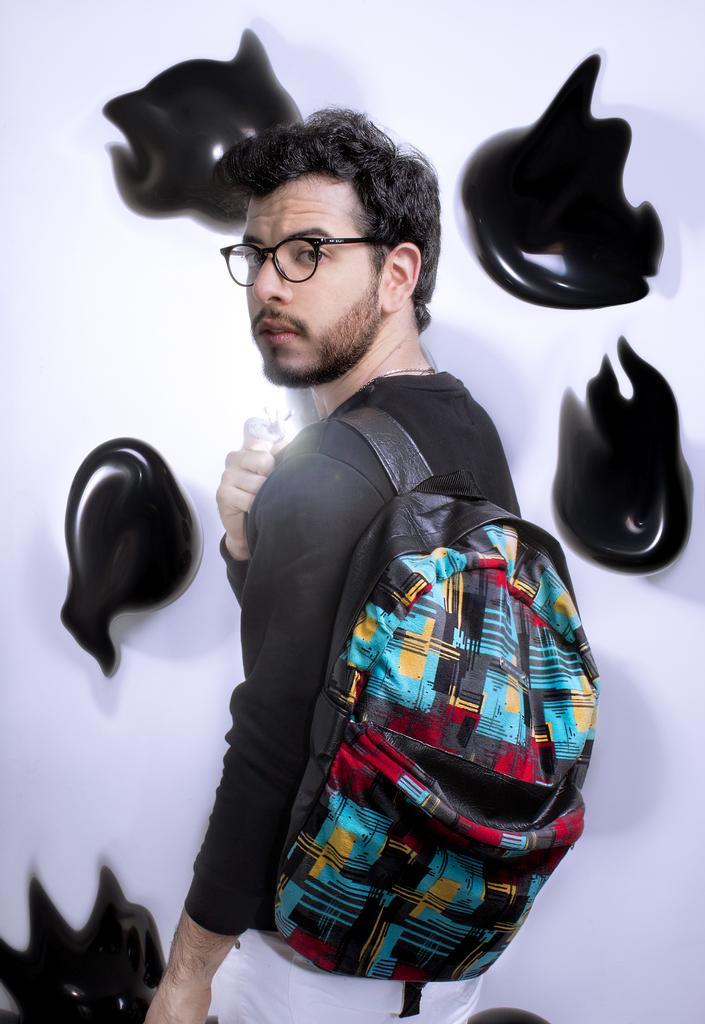How would you summarize this image in a sentence or two? In this image there is a man standing in the center wearing a bag. In the background there are objects hanged on the wall which are black in colour. 